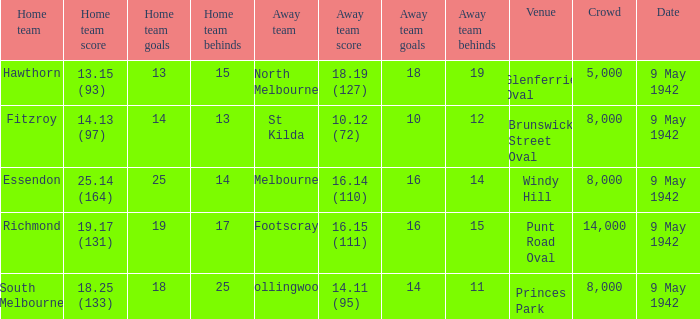How large was the crowd with a home team score of 18.25 (133)? 8000.0. 